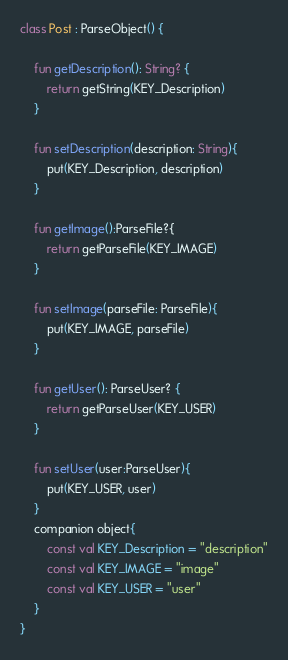<code> <loc_0><loc_0><loc_500><loc_500><_Kotlin_>class Post : ParseObject() {

    fun getDescription(): String? {
        return getString(KEY_Description)
    }

    fun setDescription(description: String){
        put(KEY_Description, description)
    }

    fun getImage():ParseFile?{
        return getParseFile(KEY_IMAGE)
    }

    fun setImage(parseFile: ParseFile){
        put(KEY_IMAGE, parseFile)
    }

    fun getUser(): ParseUser? {
        return getParseUser(KEY_USER)
    }

    fun setUser(user:ParseUser){
        put(KEY_USER, user)
    }
    companion object{
        const val KEY_Description = "description"
        const val KEY_IMAGE = "image"
        const val KEY_USER = "user"
    }
}</code> 